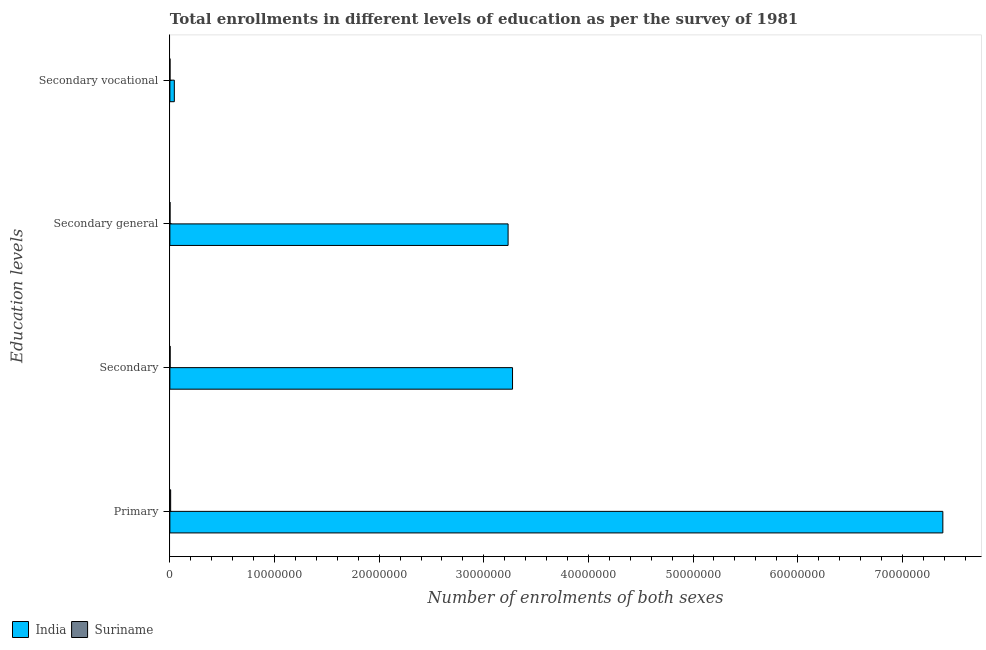Are the number of bars per tick equal to the number of legend labels?
Your answer should be very brief. Yes. Are the number of bars on each tick of the Y-axis equal?
Provide a short and direct response. Yes. How many bars are there on the 1st tick from the top?
Provide a short and direct response. 2. How many bars are there on the 3rd tick from the bottom?
Your answer should be very brief. 2. What is the label of the 3rd group of bars from the top?
Offer a very short reply. Secondary. What is the number of enrolments in secondary vocational education in Suriname?
Offer a terse response. 1.13e+04. Across all countries, what is the maximum number of enrolments in primary education?
Provide a succinct answer. 7.39e+07. Across all countries, what is the minimum number of enrolments in secondary education?
Your response must be concise. 2.40e+04. In which country was the number of enrolments in primary education maximum?
Offer a very short reply. India. In which country was the number of enrolments in secondary vocational education minimum?
Provide a succinct answer. Suriname. What is the total number of enrolments in primary education in the graph?
Your answer should be very brief. 7.39e+07. What is the difference between the number of enrolments in primary education in India and that in Suriname?
Provide a succinct answer. 7.38e+07. What is the difference between the number of enrolments in secondary vocational education in Suriname and the number of enrolments in secondary education in India?
Your answer should be very brief. -3.27e+07. What is the average number of enrolments in secondary general education per country?
Provide a short and direct response. 1.62e+07. What is the difference between the number of enrolments in primary education and number of enrolments in secondary education in Suriname?
Your response must be concise. 5.05e+04. What is the ratio of the number of enrolments in secondary vocational education in India to that in Suriname?
Make the answer very short. 37.7. Is the number of enrolments in secondary education in India less than that in Suriname?
Offer a terse response. No. What is the difference between the highest and the second highest number of enrolments in secondary education?
Your answer should be compact. 3.27e+07. What is the difference between the highest and the lowest number of enrolments in secondary general education?
Keep it short and to the point. 3.23e+07. In how many countries, is the number of enrolments in secondary education greater than the average number of enrolments in secondary education taken over all countries?
Your response must be concise. 1. Is it the case that in every country, the sum of the number of enrolments in secondary education and number of enrolments in secondary general education is greater than the sum of number of enrolments in primary education and number of enrolments in secondary vocational education?
Ensure brevity in your answer.  No. What does the 1st bar from the top in Primary represents?
Your answer should be compact. Suriname. What does the 2nd bar from the bottom in Secondary general represents?
Provide a short and direct response. Suriname. How many bars are there?
Provide a succinct answer. 8. Are all the bars in the graph horizontal?
Make the answer very short. Yes. Does the graph contain any zero values?
Offer a very short reply. No. Where does the legend appear in the graph?
Offer a very short reply. Bottom left. What is the title of the graph?
Your answer should be very brief. Total enrollments in different levels of education as per the survey of 1981. What is the label or title of the X-axis?
Make the answer very short. Number of enrolments of both sexes. What is the label or title of the Y-axis?
Your answer should be compact. Education levels. What is the Number of enrolments of both sexes in India in Primary?
Provide a short and direct response. 7.39e+07. What is the Number of enrolments of both sexes in Suriname in Primary?
Keep it short and to the point. 7.45e+04. What is the Number of enrolments of both sexes of India in Secondary?
Make the answer very short. 3.27e+07. What is the Number of enrolments of both sexes in Suriname in Secondary?
Your answer should be compact. 2.40e+04. What is the Number of enrolments of both sexes of India in Secondary general?
Provide a short and direct response. 3.23e+07. What is the Number of enrolments of both sexes of Suriname in Secondary general?
Ensure brevity in your answer.  1.27e+04. What is the Number of enrolments of both sexes of India in Secondary vocational?
Your answer should be very brief. 4.25e+05. What is the Number of enrolments of both sexes in Suriname in Secondary vocational?
Offer a very short reply. 1.13e+04. Across all Education levels, what is the maximum Number of enrolments of both sexes of India?
Keep it short and to the point. 7.39e+07. Across all Education levels, what is the maximum Number of enrolments of both sexes of Suriname?
Your response must be concise. 7.45e+04. Across all Education levels, what is the minimum Number of enrolments of both sexes of India?
Offer a terse response. 4.25e+05. Across all Education levels, what is the minimum Number of enrolments of both sexes of Suriname?
Give a very brief answer. 1.13e+04. What is the total Number of enrolments of both sexes of India in the graph?
Ensure brevity in your answer.  1.39e+08. What is the total Number of enrolments of both sexes of Suriname in the graph?
Provide a short and direct response. 1.23e+05. What is the difference between the Number of enrolments of both sexes in India in Primary and that in Secondary?
Provide a succinct answer. 4.11e+07. What is the difference between the Number of enrolments of both sexes of Suriname in Primary and that in Secondary?
Your answer should be very brief. 5.05e+04. What is the difference between the Number of enrolments of both sexes in India in Primary and that in Secondary general?
Your answer should be very brief. 4.16e+07. What is the difference between the Number of enrolments of both sexes in Suriname in Primary and that in Secondary general?
Give a very brief answer. 6.18e+04. What is the difference between the Number of enrolments of both sexes in India in Primary and that in Secondary vocational?
Provide a short and direct response. 7.34e+07. What is the difference between the Number of enrolments of both sexes of Suriname in Primary and that in Secondary vocational?
Ensure brevity in your answer.  6.33e+04. What is the difference between the Number of enrolments of both sexes of India in Secondary and that in Secondary general?
Ensure brevity in your answer.  4.25e+05. What is the difference between the Number of enrolments of both sexes in Suriname in Secondary and that in Secondary general?
Give a very brief answer. 1.13e+04. What is the difference between the Number of enrolments of both sexes in India in Secondary and that in Secondary vocational?
Keep it short and to the point. 3.23e+07. What is the difference between the Number of enrolments of both sexes of Suriname in Secondary and that in Secondary vocational?
Keep it short and to the point. 1.27e+04. What is the difference between the Number of enrolments of both sexes in India in Secondary general and that in Secondary vocational?
Keep it short and to the point. 3.19e+07. What is the difference between the Number of enrolments of both sexes of Suriname in Secondary general and that in Secondary vocational?
Offer a terse response. 1467. What is the difference between the Number of enrolments of both sexes in India in Primary and the Number of enrolments of both sexes in Suriname in Secondary?
Your answer should be compact. 7.38e+07. What is the difference between the Number of enrolments of both sexes in India in Primary and the Number of enrolments of both sexes in Suriname in Secondary general?
Provide a short and direct response. 7.39e+07. What is the difference between the Number of enrolments of both sexes in India in Primary and the Number of enrolments of both sexes in Suriname in Secondary vocational?
Your answer should be very brief. 7.39e+07. What is the difference between the Number of enrolments of both sexes in India in Secondary and the Number of enrolments of both sexes in Suriname in Secondary general?
Provide a succinct answer. 3.27e+07. What is the difference between the Number of enrolments of both sexes of India in Secondary and the Number of enrolments of both sexes of Suriname in Secondary vocational?
Ensure brevity in your answer.  3.27e+07. What is the difference between the Number of enrolments of both sexes in India in Secondary general and the Number of enrolments of both sexes in Suriname in Secondary vocational?
Offer a terse response. 3.23e+07. What is the average Number of enrolments of both sexes of India per Education levels?
Ensure brevity in your answer.  3.48e+07. What is the average Number of enrolments of both sexes in Suriname per Education levels?
Provide a short and direct response. 3.06e+04. What is the difference between the Number of enrolments of both sexes of India and Number of enrolments of both sexes of Suriname in Primary?
Ensure brevity in your answer.  7.38e+07. What is the difference between the Number of enrolments of both sexes in India and Number of enrolments of both sexes in Suriname in Secondary?
Your answer should be very brief. 3.27e+07. What is the difference between the Number of enrolments of both sexes of India and Number of enrolments of both sexes of Suriname in Secondary general?
Offer a very short reply. 3.23e+07. What is the difference between the Number of enrolments of both sexes of India and Number of enrolments of both sexes of Suriname in Secondary vocational?
Keep it short and to the point. 4.14e+05. What is the ratio of the Number of enrolments of both sexes in India in Primary to that in Secondary?
Make the answer very short. 2.26. What is the ratio of the Number of enrolments of both sexes in Suriname in Primary to that in Secondary?
Your answer should be very brief. 3.1. What is the ratio of the Number of enrolments of both sexes of India in Primary to that in Secondary general?
Keep it short and to the point. 2.29. What is the ratio of the Number of enrolments of both sexes in Suriname in Primary to that in Secondary general?
Make the answer very short. 5.85. What is the ratio of the Number of enrolments of both sexes in India in Primary to that in Secondary vocational?
Provide a succinct answer. 173.73. What is the ratio of the Number of enrolments of both sexes of Suriname in Primary to that in Secondary vocational?
Provide a succinct answer. 6.61. What is the ratio of the Number of enrolments of both sexes of India in Secondary to that in Secondary general?
Ensure brevity in your answer.  1.01. What is the ratio of the Number of enrolments of both sexes in Suriname in Secondary to that in Secondary general?
Give a very brief answer. 1.88. What is the ratio of the Number of enrolments of both sexes of India in Secondary to that in Secondary vocational?
Provide a succinct answer. 77.01. What is the ratio of the Number of enrolments of both sexes in Suriname in Secondary to that in Secondary vocational?
Your answer should be very brief. 2.13. What is the ratio of the Number of enrolments of both sexes in India in Secondary general to that in Secondary vocational?
Offer a terse response. 76.01. What is the ratio of the Number of enrolments of both sexes in Suriname in Secondary general to that in Secondary vocational?
Ensure brevity in your answer.  1.13. What is the difference between the highest and the second highest Number of enrolments of both sexes in India?
Your response must be concise. 4.11e+07. What is the difference between the highest and the second highest Number of enrolments of both sexes of Suriname?
Offer a very short reply. 5.05e+04. What is the difference between the highest and the lowest Number of enrolments of both sexes of India?
Keep it short and to the point. 7.34e+07. What is the difference between the highest and the lowest Number of enrolments of both sexes of Suriname?
Your answer should be very brief. 6.33e+04. 